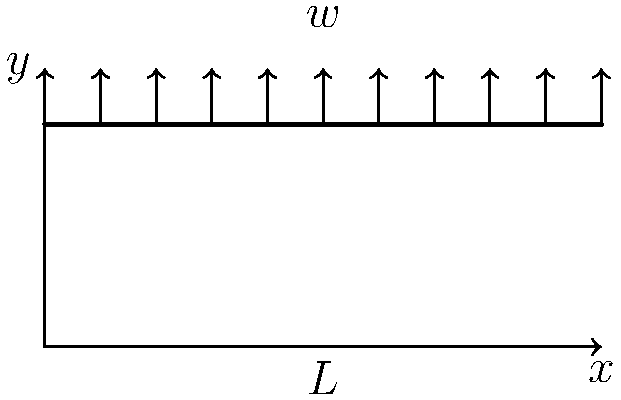As a small business owner in Woodbine, MD, you're considering expanding your workshop. You need to determine the maximum stress in a steel beam supporting the roof. The beam is 5 meters long and subjected to a uniform load of 2 kN/m. What is the maximum bending stress in the beam if its cross-section is rectangular with a width of 10 cm and a height of 20 cm? To solve this problem, we'll follow these steps:

1. Calculate the maximum bending moment:
   For a simply supported beam with uniform load, the maximum bending moment occurs at the center and is given by:
   $$M_{max} = \frac{wL^2}{8}$$
   where $w$ is the uniform load and $L$ is the beam length.
   $$M_{max} = \frac{2 \text{ kN/m} \times (5 \text{ m})^2}{8} = 6.25 \text{ kN⋅m}$$

2. Calculate the moment of inertia:
   For a rectangular cross-section, $I = \frac{bh^3}{12}$
   where $b$ is the width and $h$ is the height.
   $$I = \frac{0.1 \text{ m} \times (0.2 \text{ m})^3}{12} = 6.67 \times 10^{-5} \text{ m}^4$$

3. Calculate the distance from the neutral axis to the extreme fiber:
   For a rectangular beam, this is half the height.
   $$y = \frac{h}{2} = \frac{0.2 \text{ m}}{2} = 0.1 \text{ m}$$

4. Apply the flexure formula to calculate the maximum bending stress:
   $$\sigma_{max} = \frac{M_{max} \cdot y}{I}$$
   $$\sigma_{max} = \frac{6.25 \text{ kN⋅m} \times 0.1 \text{ m}}{6.67 \times 10^{-5} \text{ m}^4} = 9.37 \text{ MPa}$$
Answer: 9.37 MPa 